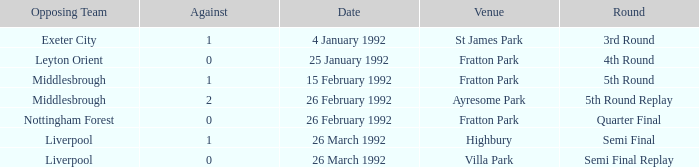What was the round for Villa Park? Semi Final Replay. 